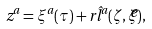<formula> <loc_0><loc_0><loc_500><loc_500>z ^ { a } = \xi ^ { a } ( \tau ) + r \hat { l } ^ { a } ( \zeta , \widetilde { \zeta } ) ,</formula> 